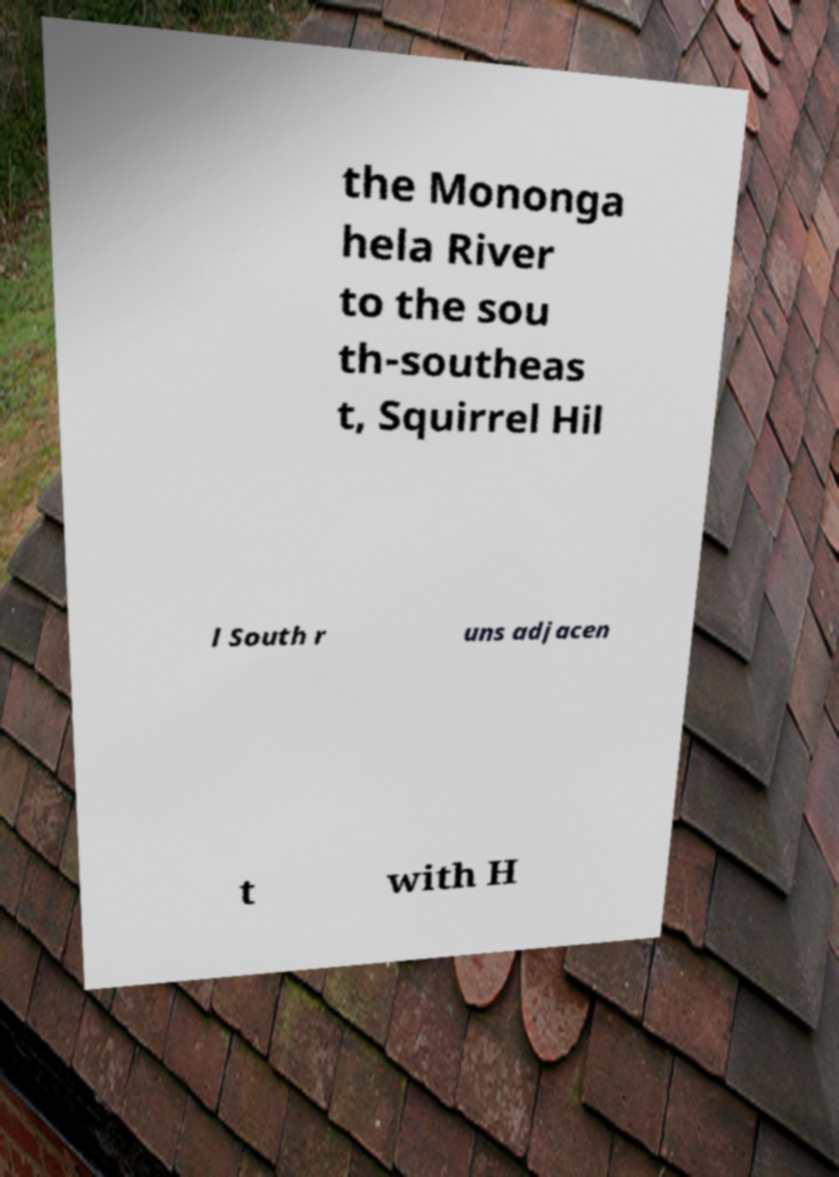For documentation purposes, I need the text within this image transcribed. Could you provide that? the Mononga hela River to the sou th-southeas t, Squirrel Hil l South r uns adjacen t with H 